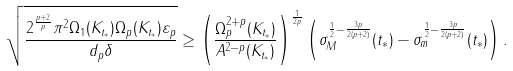<formula> <loc_0><loc_0><loc_500><loc_500>\sqrt { \frac { 2 ^ { \frac { p + 2 } { p } } \pi ^ { 2 } \Omega _ { 1 } ( K _ { t _ { \ast } } ) \Omega _ { p } ( K _ { t _ { \ast } } ) \varepsilon _ { p } } { d _ { p } \delta } } \geq \left ( \frac { \Omega _ { p } ^ { 2 + p } ( K _ { t _ { \ast } } ) } { A ^ { 2 - p } ( K _ { t _ { \ast } } ) } \right ) ^ { \frac { 1 } { 2 p } } \left ( \sigma _ { M } ^ { \frac { 1 } { 2 } - \frac { 3 p } { 2 ( p + 2 ) } } ( t _ { \ast } ) - \sigma _ { m } ^ { \frac { 1 } { 2 } - \frac { 3 p } { 2 ( p + 2 ) } } ( t _ { \ast } ) \right ) .</formula> 